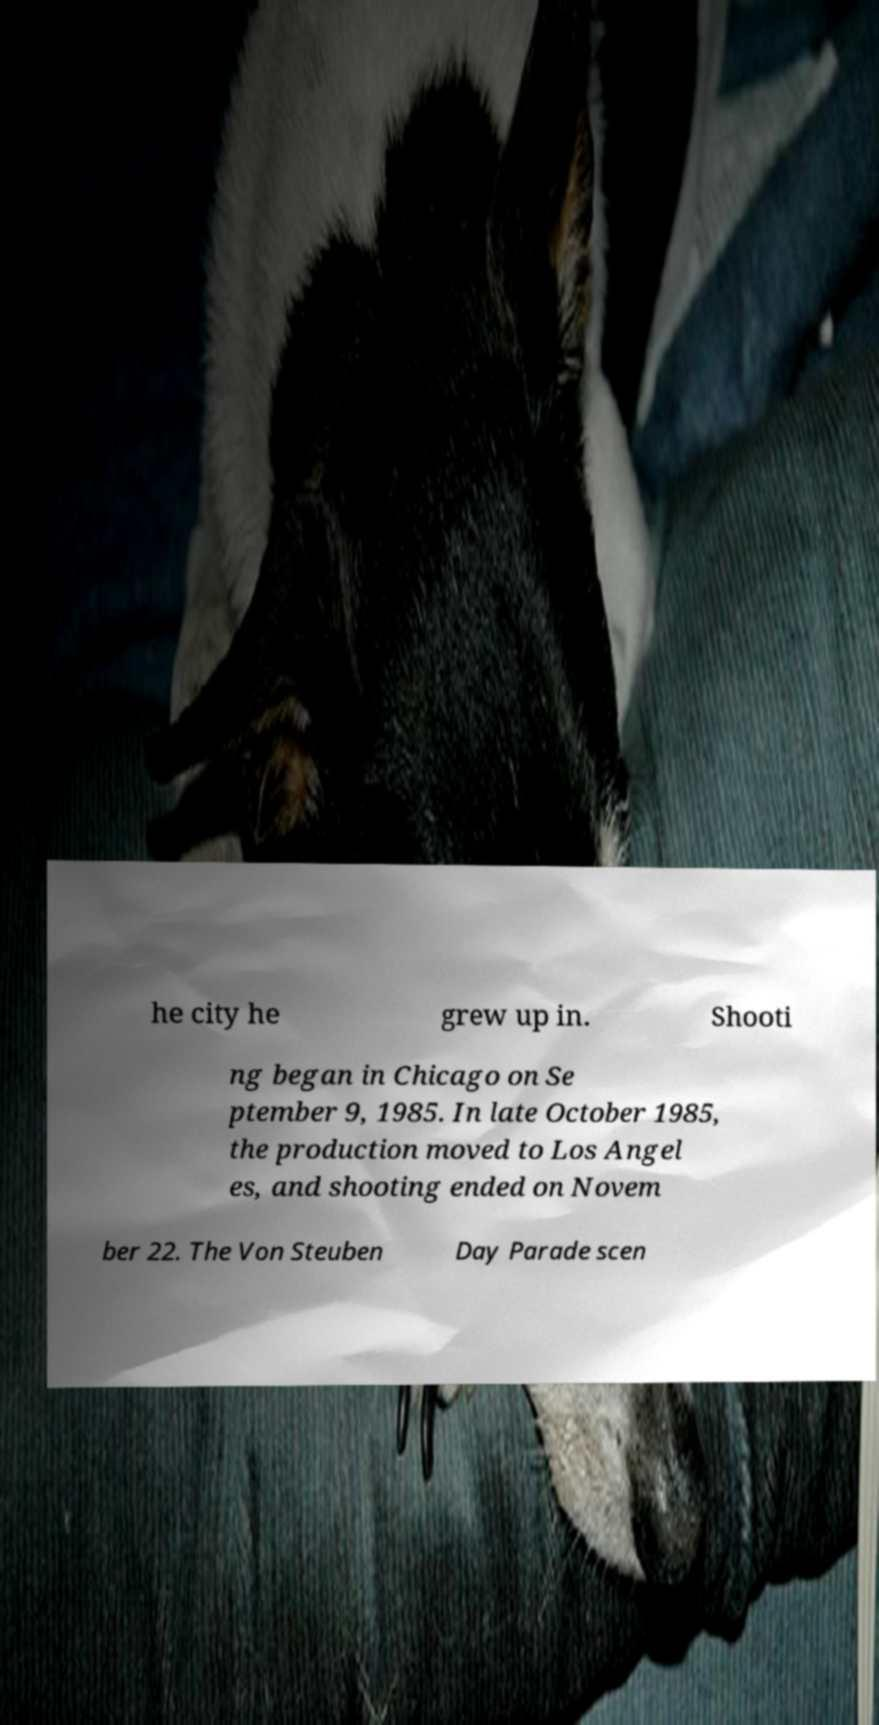There's text embedded in this image that I need extracted. Can you transcribe it verbatim? he city he grew up in. Shooti ng began in Chicago on Se ptember 9, 1985. In late October 1985, the production moved to Los Angel es, and shooting ended on Novem ber 22. The Von Steuben Day Parade scen 